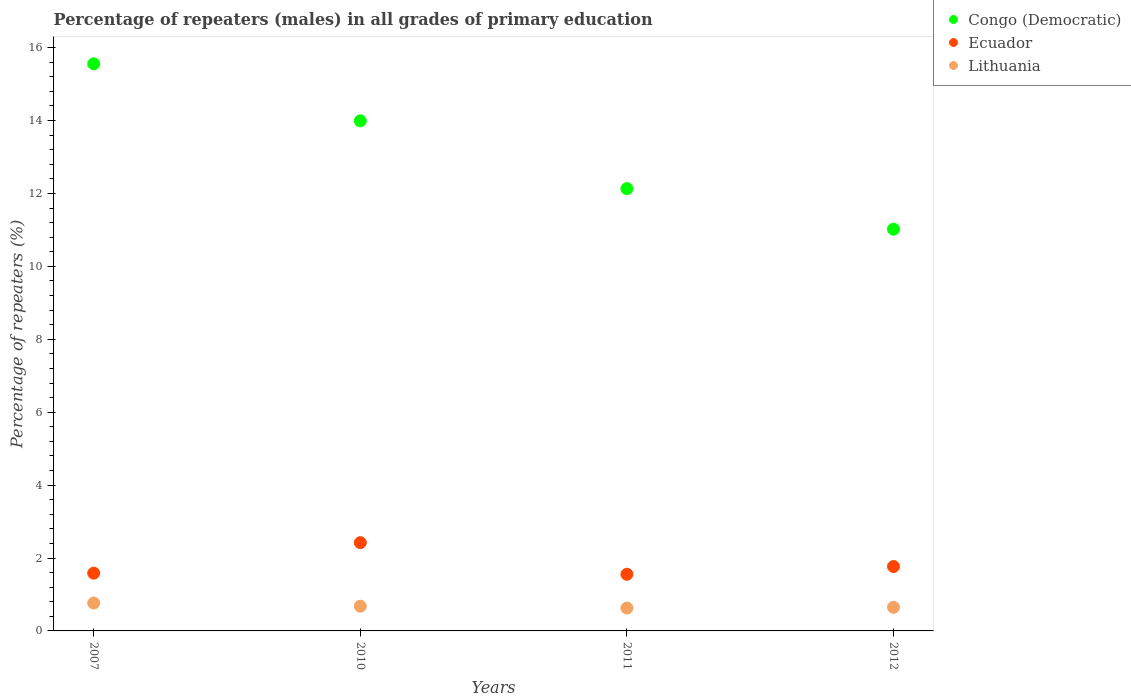Is the number of dotlines equal to the number of legend labels?
Keep it short and to the point. Yes. What is the percentage of repeaters (males) in Ecuador in 2007?
Provide a succinct answer. 1.58. Across all years, what is the maximum percentage of repeaters (males) in Congo (Democratic)?
Make the answer very short. 15.56. Across all years, what is the minimum percentage of repeaters (males) in Lithuania?
Give a very brief answer. 0.63. What is the total percentage of repeaters (males) in Lithuania in the graph?
Your response must be concise. 2.72. What is the difference between the percentage of repeaters (males) in Congo (Democratic) in 2007 and that in 2012?
Ensure brevity in your answer.  4.54. What is the difference between the percentage of repeaters (males) in Lithuania in 2011 and the percentage of repeaters (males) in Ecuador in 2007?
Your answer should be compact. -0.96. What is the average percentage of repeaters (males) in Congo (Democratic) per year?
Provide a short and direct response. 13.18. In the year 2012, what is the difference between the percentage of repeaters (males) in Lithuania and percentage of repeaters (males) in Ecuador?
Provide a short and direct response. -1.12. What is the ratio of the percentage of repeaters (males) in Lithuania in 2007 to that in 2012?
Provide a succinct answer. 1.18. What is the difference between the highest and the second highest percentage of repeaters (males) in Ecuador?
Offer a terse response. 0.66. What is the difference between the highest and the lowest percentage of repeaters (males) in Lithuania?
Keep it short and to the point. 0.14. In how many years, is the percentage of repeaters (males) in Ecuador greater than the average percentage of repeaters (males) in Ecuador taken over all years?
Your answer should be compact. 1. Does the percentage of repeaters (males) in Ecuador monotonically increase over the years?
Keep it short and to the point. No. Is the percentage of repeaters (males) in Lithuania strictly less than the percentage of repeaters (males) in Congo (Democratic) over the years?
Provide a succinct answer. Yes. How many years are there in the graph?
Keep it short and to the point. 4. Does the graph contain any zero values?
Give a very brief answer. No. How many legend labels are there?
Your answer should be compact. 3. What is the title of the graph?
Make the answer very short. Percentage of repeaters (males) in all grades of primary education. Does "Burkina Faso" appear as one of the legend labels in the graph?
Offer a terse response. No. What is the label or title of the Y-axis?
Offer a terse response. Percentage of repeaters (%). What is the Percentage of repeaters (%) of Congo (Democratic) in 2007?
Offer a very short reply. 15.56. What is the Percentage of repeaters (%) of Ecuador in 2007?
Your answer should be compact. 1.58. What is the Percentage of repeaters (%) of Lithuania in 2007?
Your answer should be compact. 0.76. What is the Percentage of repeaters (%) in Congo (Democratic) in 2010?
Offer a very short reply. 13.99. What is the Percentage of repeaters (%) of Ecuador in 2010?
Offer a very short reply. 2.42. What is the Percentage of repeaters (%) of Lithuania in 2010?
Make the answer very short. 0.68. What is the Percentage of repeaters (%) in Congo (Democratic) in 2011?
Provide a short and direct response. 12.13. What is the Percentage of repeaters (%) of Ecuador in 2011?
Ensure brevity in your answer.  1.55. What is the Percentage of repeaters (%) of Lithuania in 2011?
Offer a very short reply. 0.63. What is the Percentage of repeaters (%) of Congo (Democratic) in 2012?
Your response must be concise. 11.02. What is the Percentage of repeaters (%) in Ecuador in 2012?
Your response must be concise. 1.77. What is the Percentage of repeaters (%) of Lithuania in 2012?
Make the answer very short. 0.65. Across all years, what is the maximum Percentage of repeaters (%) in Congo (Democratic)?
Your response must be concise. 15.56. Across all years, what is the maximum Percentage of repeaters (%) in Ecuador?
Provide a short and direct response. 2.42. Across all years, what is the maximum Percentage of repeaters (%) of Lithuania?
Your answer should be very brief. 0.76. Across all years, what is the minimum Percentage of repeaters (%) of Congo (Democratic)?
Keep it short and to the point. 11.02. Across all years, what is the minimum Percentage of repeaters (%) of Ecuador?
Make the answer very short. 1.55. Across all years, what is the minimum Percentage of repeaters (%) in Lithuania?
Provide a succinct answer. 0.63. What is the total Percentage of repeaters (%) of Congo (Democratic) in the graph?
Give a very brief answer. 52.71. What is the total Percentage of repeaters (%) in Ecuador in the graph?
Offer a very short reply. 7.33. What is the total Percentage of repeaters (%) in Lithuania in the graph?
Offer a terse response. 2.72. What is the difference between the Percentage of repeaters (%) in Congo (Democratic) in 2007 and that in 2010?
Keep it short and to the point. 1.56. What is the difference between the Percentage of repeaters (%) of Ecuador in 2007 and that in 2010?
Your answer should be very brief. -0.84. What is the difference between the Percentage of repeaters (%) in Lithuania in 2007 and that in 2010?
Make the answer very short. 0.09. What is the difference between the Percentage of repeaters (%) in Congo (Democratic) in 2007 and that in 2011?
Ensure brevity in your answer.  3.42. What is the difference between the Percentage of repeaters (%) in Ecuador in 2007 and that in 2011?
Provide a succinct answer. 0.03. What is the difference between the Percentage of repeaters (%) of Lithuania in 2007 and that in 2011?
Give a very brief answer. 0.14. What is the difference between the Percentage of repeaters (%) in Congo (Democratic) in 2007 and that in 2012?
Offer a terse response. 4.54. What is the difference between the Percentage of repeaters (%) of Ecuador in 2007 and that in 2012?
Your response must be concise. -0.18. What is the difference between the Percentage of repeaters (%) of Lithuania in 2007 and that in 2012?
Ensure brevity in your answer.  0.12. What is the difference between the Percentage of repeaters (%) of Congo (Democratic) in 2010 and that in 2011?
Give a very brief answer. 1.86. What is the difference between the Percentage of repeaters (%) in Ecuador in 2010 and that in 2011?
Keep it short and to the point. 0.87. What is the difference between the Percentage of repeaters (%) in Lithuania in 2010 and that in 2011?
Your response must be concise. 0.05. What is the difference between the Percentage of repeaters (%) of Congo (Democratic) in 2010 and that in 2012?
Give a very brief answer. 2.97. What is the difference between the Percentage of repeaters (%) of Ecuador in 2010 and that in 2012?
Make the answer very short. 0.66. What is the difference between the Percentage of repeaters (%) in Congo (Democratic) in 2011 and that in 2012?
Your response must be concise. 1.11. What is the difference between the Percentage of repeaters (%) in Ecuador in 2011 and that in 2012?
Your response must be concise. -0.21. What is the difference between the Percentage of repeaters (%) of Lithuania in 2011 and that in 2012?
Keep it short and to the point. -0.02. What is the difference between the Percentage of repeaters (%) of Congo (Democratic) in 2007 and the Percentage of repeaters (%) of Ecuador in 2010?
Offer a terse response. 13.14. What is the difference between the Percentage of repeaters (%) of Congo (Democratic) in 2007 and the Percentage of repeaters (%) of Lithuania in 2010?
Provide a succinct answer. 14.88. What is the difference between the Percentage of repeaters (%) in Ecuador in 2007 and the Percentage of repeaters (%) in Lithuania in 2010?
Offer a very short reply. 0.91. What is the difference between the Percentage of repeaters (%) of Congo (Democratic) in 2007 and the Percentage of repeaters (%) of Ecuador in 2011?
Your answer should be compact. 14. What is the difference between the Percentage of repeaters (%) of Congo (Democratic) in 2007 and the Percentage of repeaters (%) of Lithuania in 2011?
Ensure brevity in your answer.  14.93. What is the difference between the Percentage of repeaters (%) of Ecuador in 2007 and the Percentage of repeaters (%) of Lithuania in 2011?
Provide a succinct answer. 0.96. What is the difference between the Percentage of repeaters (%) in Congo (Democratic) in 2007 and the Percentage of repeaters (%) in Ecuador in 2012?
Give a very brief answer. 13.79. What is the difference between the Percentage of repeaters (%) of Congo (Democratic) in 2007 and the Percentage of repeaters (%) of Lithuania in 2012?
Keep it short and to the point. 14.91. What is the difference between the Percentage of repeaters (%) of Ecuador in 2007 and the Percentage of repeaters (%) of Lithuania in 2012?
Provide a succinct answer. 0.94. What is the difference between the Percentage of repeaters (%) in Congo (Democratic) in 2010 and the Percentage of repeaters (%) in Ecuador in 2011?
Provide a succinct answer. 12.44. What is the difference between the Percentage of repeaters (%) of Congo (Democratic) in 2010 and the Percentage of repeaters (%) of Lithuania in 2011?
Ensure brevity in your answer.  13.37. What is the difference between the Percentage of repeaters (%) in Ecuador in 2010 and the Percentage of repeaters (%) in Lithuania in 2011?
Your response must be concise. 1.79. What is the difference between the Percentage of repeaters (%) of Congo (Democratic) in 2010 and the Percentage of repeaters (%) of Ecuador in 2012?
Make the answer very short. 12.23. What is the difference between the Percentage of repeaters (%) of Congo (Democratic) in 2010 and the Percentage of repeaters (%) of Lithuania in 2012?
Provide a succinct answer. 13.35. What is the difference between the Percentage of repeaters (%) of Ecuador in 2010 and the Percentage of repeaters (%) of Lithuania in 2012?
Keep it short and to the point. 1.77. What is the difference between the Percentage of repeaters (%) in Congo (Democratic) in 2011 and the Percentage of repeaters (%) in Ecuador in 2012?
Provide a succinct answer. 10.37. What is the difference between the Percentage of repeaters (%) of Congo (Democratic) in 2011 and the Percentage of repeaters (%) of Lithuania in 2012?
Ensure brevity in your answer.  11.49. What is the difference between the Percentage of repeaters (%) in Ecuador in 2011 and the Percentage of repeaters (%) in Lithuania in 2012?
Your answer should be compact. 0.91. What is the average Percentage of repeaters (%) in Congo (Democratic) per year?
Provide a succinct answer. 13.18. What is the average Percentage of repeaters (%) in Ecuador per year?
Offer a terse response. 1.83. What is the average Percentage of repeaters (%) in Lithuania per year?
Ensure brevity in your answer.  0.68. In the year 2007, what is the difference between the Percentage of repeaters (%) of Congo (Democratic) and Percentage of repeaters (%) of Ecuador?
Make the answer very short. 13.97. In the year 2007, what is the difference between the Percentage of repeaters (%) in Congo (Democratic) and Percentage of repeaters (%) in Lithuania?
Your answer should be very brief. 14.79. In the year 2007, what is the difference between the Percentage of repeaters (%) in Ecuador and Percentage of repeaters (%) in Lithuania?
Provide a short and direct response. 0.82. In the year 2010, what is the difference between the Percentage of repeaters (%) of Congo (Democratic) and Percentage of repeaters (%) of Ecuador?
Give a very brief answer. 11.57. In the year 2010, what is the difference between the Percentage of repeaters (%) of Congo (Democratic) and Percentage of repeaters (%) of Lithuania?
Your response must be concise. 13.32. In the year 2010, what is the difference between the Percentage of repeaters (%) in Ecuador and Percentage of repeaters (%) in Lithuania?
Ensure brevity in your answer.  1.74. In the year 2011, what is the difference between the Percentage of repeaters (%) in Congo (Democratic) and Percentage of repeaters (%) in Ecuador?
Offer a terse response. 10.58. In the year 2011, what is the difference between the Percentage of repeaters (%) of Congo (Democratic) and Percentage of repeaters (%) of Lithuania?
Make the answer very short. 11.51. In the year 2011, what is the difference between the Percentage of repeaters (%) of Ecuador and Percentage of repeaters (%) of Lithuania?
Ensure brevity in your answer.  0.93. In the year 2012, what is the difference between the Percentage of repeaters (%) in Congo (Democratic) and Percentage of repeaters (%) in Ecuador?
Your answer should be very brief. 9.25. In the year 2012, what is the difference between the Percentage of repeaters (%) of Congo (Democratic) and Percentage of repeaters (%) of Lithuania?
Make the answer very short. 10.37. In the year 2012, what is the difference between the Percentage of repeaters (%) of Ecuador and Percentage of repeaters (%) of Lithuania?
Your answer should be compact. 1.12. What is the ratio of the Percentage of repeaters (%) of Congo (Democratic) in 2007 to that in 2010?
Your answer should be very brief. 1.11. What is the ratio of the Percentage of repeaters (%) of Ecuador in 2007 to that in 2010?
Provide a short and direct response. 0.65. What is the ratio of the Percentage of repeaters (%) of Lithuania in 2007 to that in 2010?
Your answer should be compact. 1.13. What is the ratio of the Percentage of repeaters (%) of Congo (Democratic) in 2007 to that in 2011?
Ensure brevity in your answer.  1.28. What is the ratio of the Percentage of repeaters (%) of Ecuador in 2007 to that in 2011?
Provide a succinct answer. 1.02. What is the ratio of the Percentage of repeaters (%) in Lithuania in 2007 to that in 2011?
Provide a succinct answer. 1.22. What is the ratio of the Percentage of repeaters (%) of Congo (Democratic) in 2007 to that in 2012?
Keep it short and to the point. 1.41. What is the ratio of the Percentage of repeaters (%) in Ecuador in 2007 to that in 2012?
Your answer should be very brief. 0.9. What is the ratio of the Percentage of repeaters (%) of Lithuania in 2007 to that in 2012?
Your answer should be compact. 1.18. What is the ratio of the Percentage of repeaters (%) of Congo (Democratic) in 2010 to that in 2011?
Provide a short and direct response. 1.15. What is the ratio of the Percentage of repeaters (%) in Ecuador in 2010 to that in 2011?
Your answer should be very brief. 1.56. What is the ratio of the Percentage of repeaters (%) in Lithuania in 2010 to that in 2011?
Offer a terse response. 1.08. What is the ratio of the Percentage of repeaters (%) of Congo (Democratic) in 2010 to that in 2012?
Make the answer very short. 1.27. What is the ratio of the Percentage of repeaters (%) in Ecuador in 2010 to that in 2012?
Your response must be concise. 1.37. What is the ratio of the Percentage of repeaters (%) in Lithuania in 2010 to that in 2012?
Keep it short and to the point. 1.05. What is the ratio of the Percentage of repeaters (%) in Congo (Democratic) in 2011 to that in 2012?
Provide a short and direct response. 1.1. What is the ratio of the Percentage of repeaters (%) of Ecuador in 2011 to that in 2012?
Provide a short and direct response. 0.88. What is the ratio of the Percentage of repeaters (%) of Lithuania in 2011 to that in 2012?
Provide a succinct answer. 0.97. What is the difference between the highest and the second highest Percentage of repeaters (%) in Congo (Democratic)?
Provide a short and direct response. 1.56. What is the difference between the highest and the second highest Percentage of repeaters (%) of Ecuador?
Provide a short and direct response. 0.66. What is the difference between the highest and the second highest Percentage of repeaters (%) in Lithuania?
Your answer should be compact. 0.09. What is the difference between the highest and the lowest Percentage of repeaters (%) in Congo (Democratic)?
Give a very brief answer. 4.54. What is the difference between the highest and the lowest Percentage of repeaters (%) of Ecuador?
Provide a short and direct response. 0.87. What is the difference between the highest and the lowest Percentage of repeaters (%) of Lithuania?
Your answer should be very brief. 0.14. 